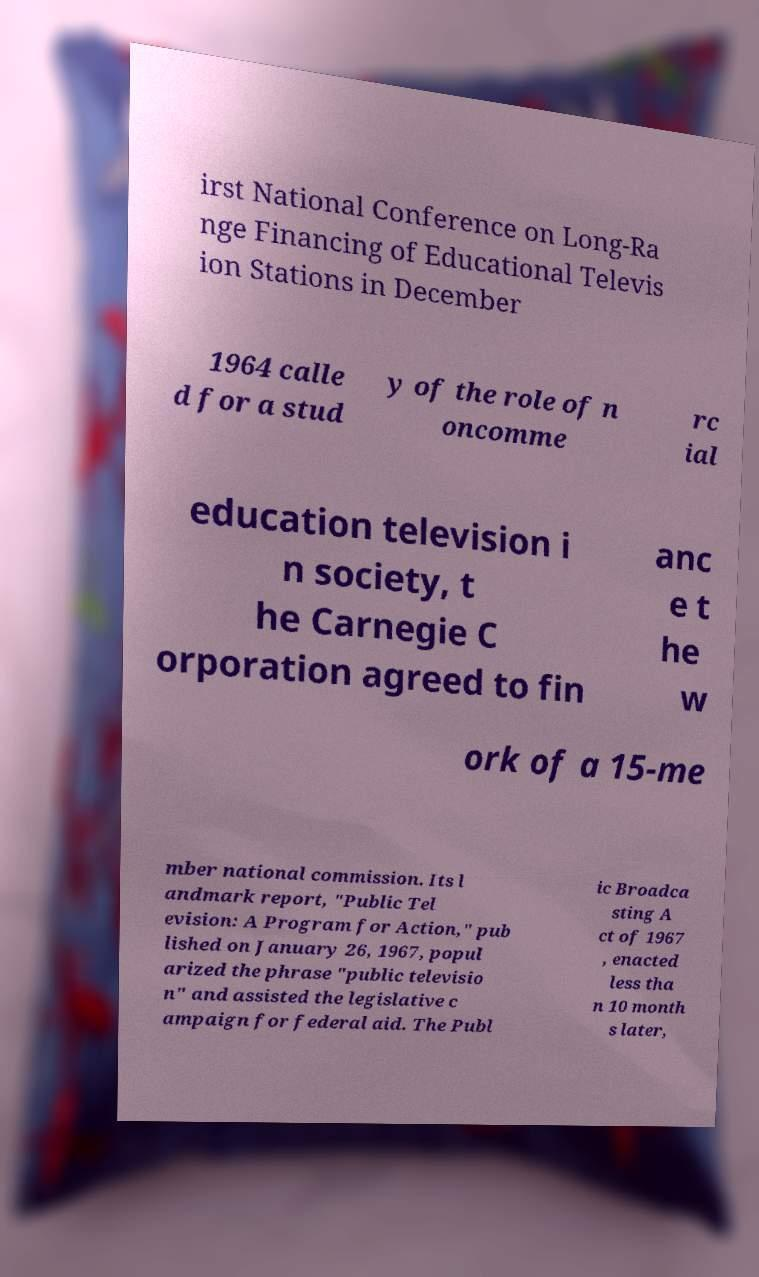Please read and relay the text visible in this image. What does it say? irst National Conference on Long-Ra nge Financing of Educational Televis ion Stations in December 1964 calle d for a stud y of the role of n oncomme rc ial education television i n society, t he Carnegie C orporation agreed to fin anc e t he w ork of a 15-me mber national commission. Its l andmark report, "Public Tel evision: A Program for Action," pub lished on January 26, 1967, popul arized the phrase "public televisio n" and assisted the legislative c ampaign for federal aid. The Publ ic Broadca sting A ct of 1967 , enacted less tha n 10 month s later, 